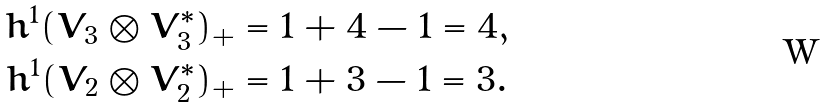<formula> <loc_0><loc_0><loc_500><loc_500>h ^ { 1 } ( V _ { 3 } \otimes V _ { 3 } ^ { * } ) _ { + } & = 1 + 4 - 1 = 4 , \\ h ^ { 1 } ( V _ { 2 } \otimes V _ { 2 } ^ { * } ) _ { + } & = 1 + 3 - 1 = 3 .</formula> 